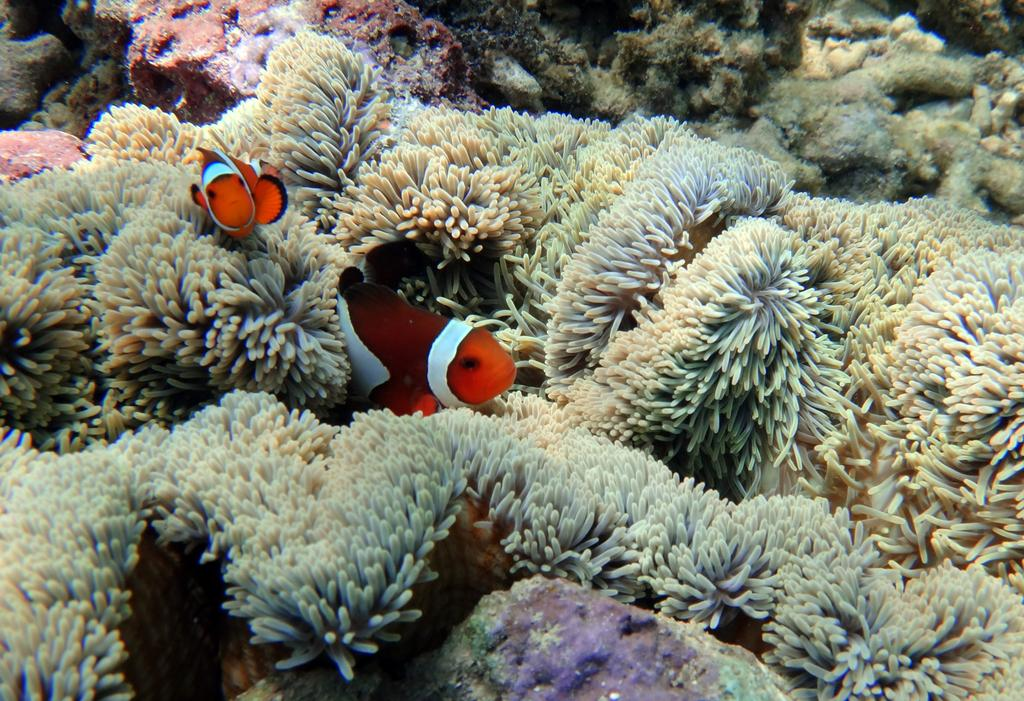What type of animals can be seen in the image? There are fishes in the water. What colors are the fishes in the image? The fishes are in orange and white color. What can be seen at the bottom of the image? There are marine plants at the bottom of the image. What other object is present in the image? There is a rock in the image. What type of creature is washing the zebra in the image? There is no creature washing a zebra in the image; it features fishes in the water with marine plants and a rock. 